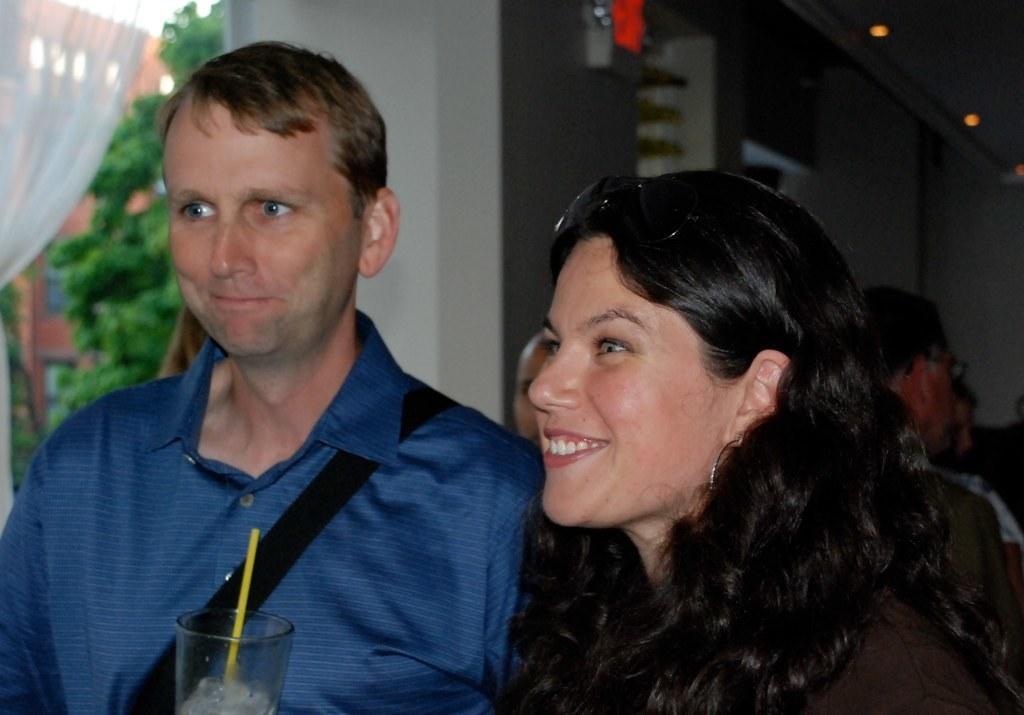Describe this image in one or two sentences. In this image we can see group of persons. One woman is wearing goggles on her head. One person is holding a glass with straw in it. In the background, we can see group of lights, pillars, trees, curtain, a building with windows and the sky. 